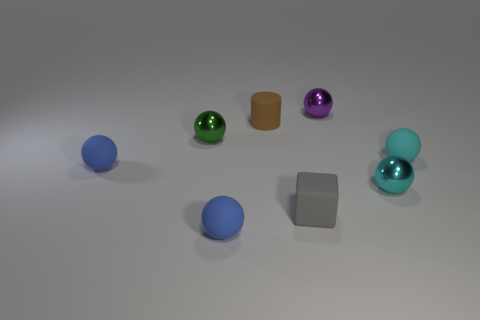How many blue spheres must be subtracted to get 1 blue spheres? 1 Subtract all tiny cyan matte balls. How many balls are left? 5 Subtract all cyan balls. How many balls are left? 4 Add 1 gray rubber objects. How many objects exist? 9 Subtract all blocks. How many objects are left? 7 Subtract all brown cubes. Subtract all red cylinders. How many cubes are left? 1 Subtract all blue cylinders. How many brown balls are left? 0 Subtract all big yellow objects. Subtract all cylinders. How many objects are left? 7 Add 8 tiny cyan rubber spheres. How many tiny cyan rubber spheres are left? 9 Add 1 big cyan balls. How many big cyan balls exist? 1 